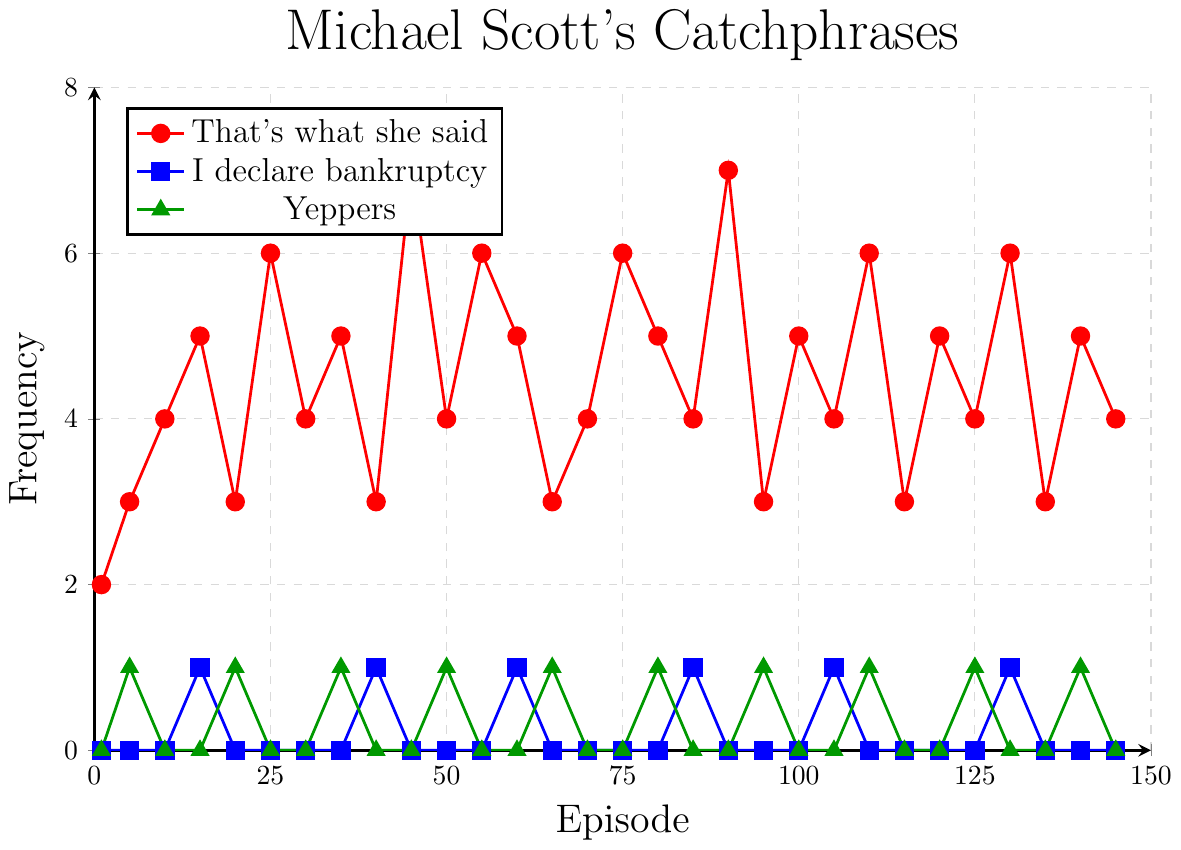What is the overall trend in the frequency of "That's what she said" across episodes? The frequency of "That's what she said" generally increases over the episodes, with occasional dips. The highest frequency observed is 7 in episodes 45 and 90.
Answer: Increasing with occasional dips In which episode does "Yeppers" first appear? "Yeppers" first appears in episode 5, as indicated by the green triangle mark at episode 5 on the plot.
Answer: Episode 5 Compare the frequency of "I declare bankruptcy" in episodes 15 and 40. "I declare bankruptcy" is mentioned once in episode 15 and once in episode 40, showing equal frequency for both episodes.
Answer: Equal frequency Which catchphrase has the highest recorded single-episode frequency, and what is the value? The highest recorded single-episode frequency is for "That's what she said," which peaks at 7 in episodes 45 and 90, as indicated by the red circles.
Answer: "That's what she said," 7 Count the total episodes where "I declare bankruptcy" is mentioned. The blue squares (representing "I declare bankruptcy") appear in episodes 15, 40, 60, 85, 105, and 130, for a total of 6 episodes.
Answer: 6 episodes What is the combined frequency of all catchphrases in episode 25? In episode 25, "That's what she said" is mentioned 6 times and "Yeppers" is mentioned 0 times while "I declare bankruptcy" is not mentioned. The combined frequency is 6 + 0 + 0 = 6.
Answer: 6 During which episodes do all three catchphrases appear in the same episode? All three catchphrases appear only in episode 15, as all red, blue, and green marks (representing "That's what she said," "I declare bankruptcy," and "Yeppers") are visible in the plot.
Answer: Episode 15 Which catchphrase shows the greatest fluctuation in its frequency over the episodes? "That's what she said" shows the greatest fluctuation in frequency, with values ranging from 2 to 7, as reflected in the varied heights of red circles on the plot.
Answer: "That's what she said" What is the frequency difference between "That's what she said" and "Yeppers" in episode 140? In episode 140, "That's what she said" is mentioned 5 times and "Yeppers" is mentioned once. The difference is 5 - 1 = 4.
Answer: 4 Among the three catchphrases, which one has the least appearances overall? "I declare bankruptcy" has the least appearances overall, as indicated by the fewer blue squares compared to red circles and green triangles.
Answer: "I declare bankruptcy" 